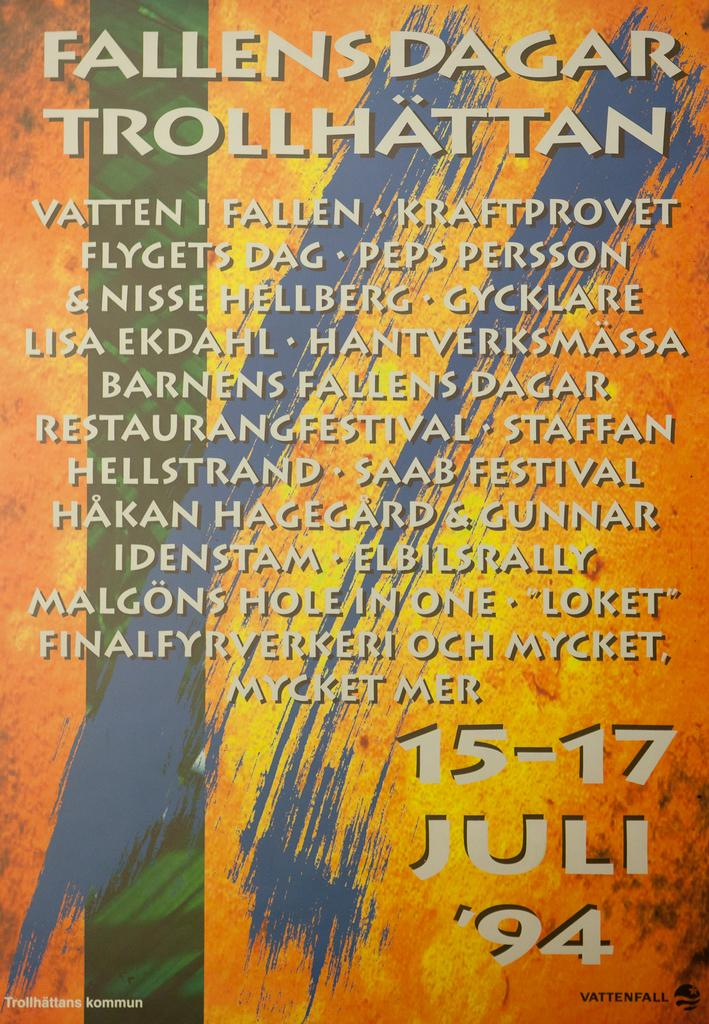<image>
Give a short and clear explanation of the subsequent image. A colorful sign from 1994 is for the Fallens Dagar Trollhattan. 